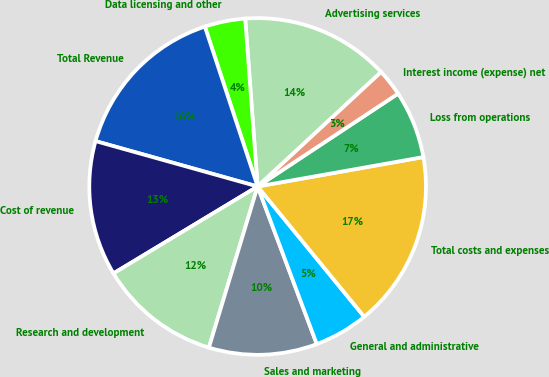Convert chart. <chart><loc_0><loc_0><loc_500><loc_500><pie_chart><fcel>Advertising services<fcel>Data licensing and other<fcel>Total Revenue<fcel>Cost of revenue<fcel>Research and development<fcel>Sales and marketing<fcel>General and administrative<fcel>Total costs and expenses<fcel>Loss from operations<fcel>Interest income (expense) net<nl><fcel>14.28%<fcel>3.9%<fcel>15.58%<fcel>12.98%<fcel>11.69%<fcel>10.39%<fcel>5.2%<fcel>16.88%<fcel>6.5%<fcel>2.6%<nl></chart> 